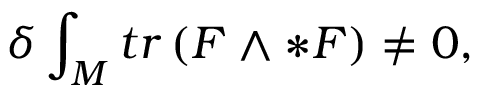<formula> <loc_0><loc_0><loc_500><loc_500>\delta \int _ { M } t r \left ( F \wedge * F \right ) \neq 0 ,</formula> 